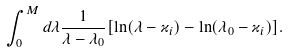Convert formula to latex. <formula><loc_0><loc_0><loc_500><loc_500>\int _ { 0 } ^ { M } d \lambda \frac { 1 } { \lambda - \lambda _ { 0 } } [ \ln ( \lambda - \varkappa _ { i } ) - \ln ( \lambda _ { 0 } - \varkappa _ { i } ) ] .</formula> 